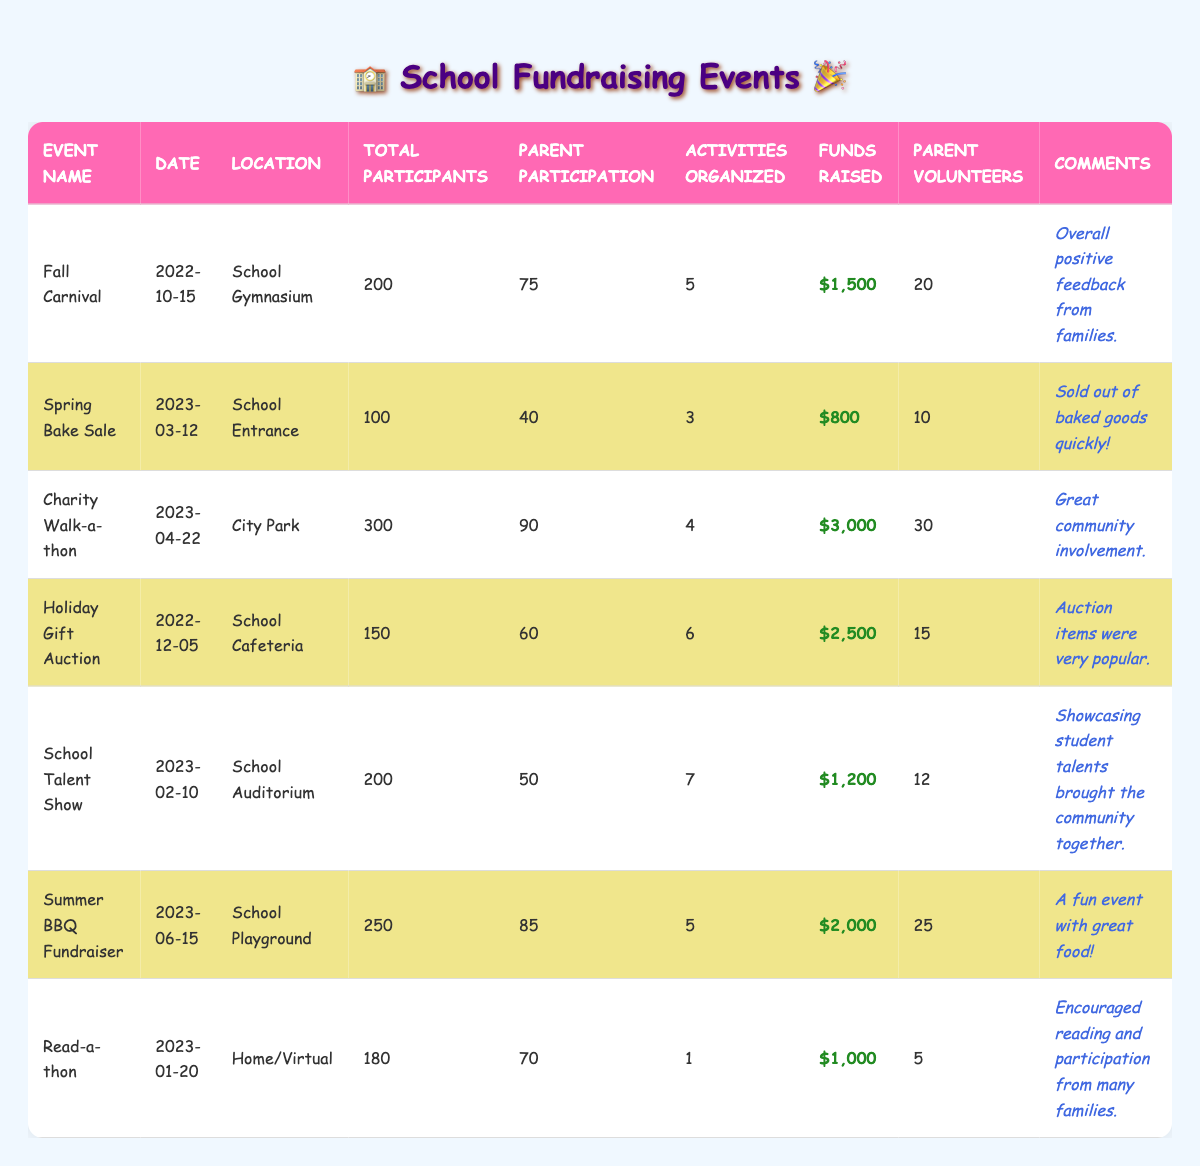What was the total funds raised from all events combined? To find the total funds raised, sum the funds from each event: $1,500 (Fall Carnival) + $800 (Spring Bake Sale) + $3,000 (Charity Walk-a-thon) + $2,500 (Holiday Gift Auction) + $1,200 (School Talent Show) + $2,000 (Summer BBQ Fundraiser) + $1,000 (Read-a-thon) = $12,000.
Answer: $12,000 What is the event with the highest parent participation? Compare the parent participation numbers: 75 (Fall Carnival), 40 (Spring Bake Sale), 90 (Charity Walk-a-thon), 60 (Holiday Gift Auction), 50 (School Talent Show), 85 (Summer BBQ Fundraiser), and 70 (Read-a-thon). The highest is 90 from the Charity Walk-a-thon.
Answer: Charity Walk-a-thon How many parent volunteers were involved in the Holiday Gift Auction? Refer directly to the table entry for the Holiday Gift Auction, which states that 15 parent volunteers participated.
Answer: 15 What percentage of total participants were parents at the Spring Bake Sale? Calculate the percentage using the formula: (Parent Participation / Total Participants) * 100. So, (40 / 100) * 100 = 40%.
Answer: 40% How many more parent volunteers were there in the Charity Walk-a-thon compared to the School Talent Show? Look at the number of parent volunteers: 30 (Charity Walk-a-thon) and 12 (School Talent Show). The difference is 30 - 12 = 18.
Answer: 18 Did the Summer BBQ Fundraiser generate more funds than the Charity Walk-a-thon? Compare the funds raised from both events: $2,000 (Summer BBQ Fundraiser) and $3,000 (Charity Walk-a-thon). Since $2,000 is less than $3,000, the statement is false.
Answer: No What was the average number of activities organized across all events? To find the average, sum the activities organized (5 + 3 + 4 + 6 + 7 + 5 + 1 = 31) and divide by the number of events (7). So, 31 / 7 = approximately 4.43.
Answer: 4.43 How many more participants were at the Charity Walk-a-thon than at the Spring Bake Sale? Compare the total participants: 300 (Charity Walk-a-thon) and 100 (Spring Bake Sale). The difference is 300 - 100 = 200.
Answer: 200 Which event had the highest funds raised per parent volunteer? First, calculate the funds raised per volunteer for each event: Charity Walk-a-thon: $3,000 / 30 = $100, Summer BBQ: $2,000 / 25 = $80, etc. The Charity Walk-a-thon yields the highest at $100 per volunteer.
Answer: Charity Walk-a-thon How many events had more than 70 parent participants? Count the events with parent participation above 70: Charity Walk-a-thon (90), Summer BBQ Fundraiser (85), Read-a-thon (70), and Fall Carnival (75) = 4 events.
Answer: 4 What was the total number of activities organized for all events? Simply sum the activities organized: 5 + 3 + 4 + 6 + 7 + 5 + 1 = 31.
Answer: 31 